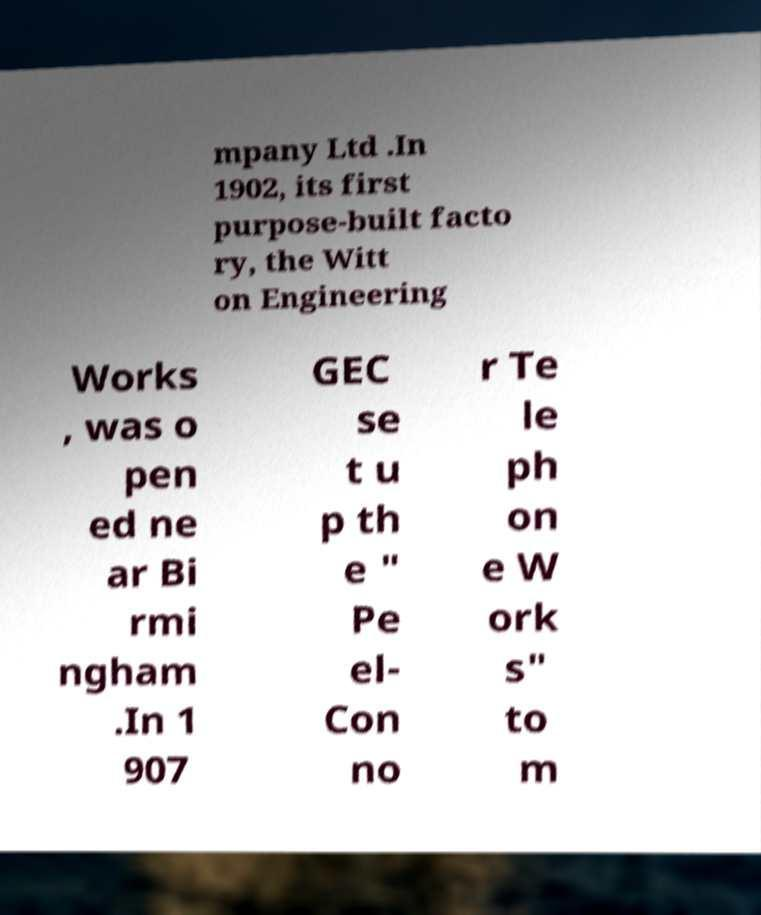What messages or text are displayed in this image? I need them in a readable, typed format. mpany Ltd .In 1902, its first purpose-built facto ry, the Witt on Engineering Works , was o pen ed ne ar Bi rmi ngham .In 1 907 GEC se t u p th e " Pe el- Con no r Te le ph on e W ork s" to m 